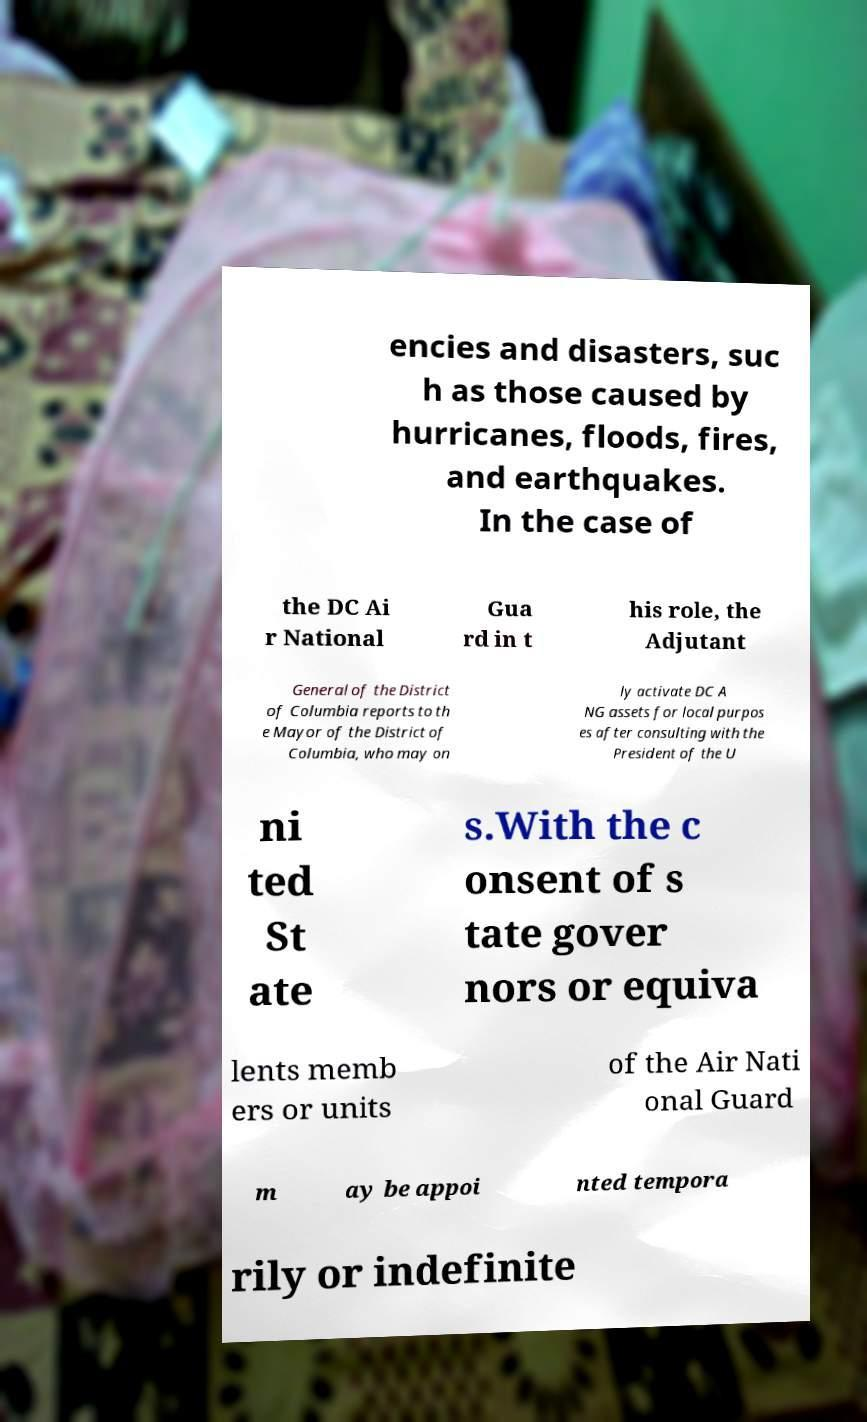Could you extract and type out the text from this image? encies and disasters, suc h as those caused by hurricanes, floods, fires, and earthquakes. In the case of the DC Ai r National Gua rd in t his role, the Adjutant General of the District of Columbia reports to th e Mayor of the District of Columbia, who may on ly activate DC A NG assets for local purpos es after consulting with the President of the U ni ted St ate s.With the c onsent of s tate gover nors or equiva lents memb ers or units of the Air Nati onal Guard m ay be appoi nted tempora rily or indefinite 